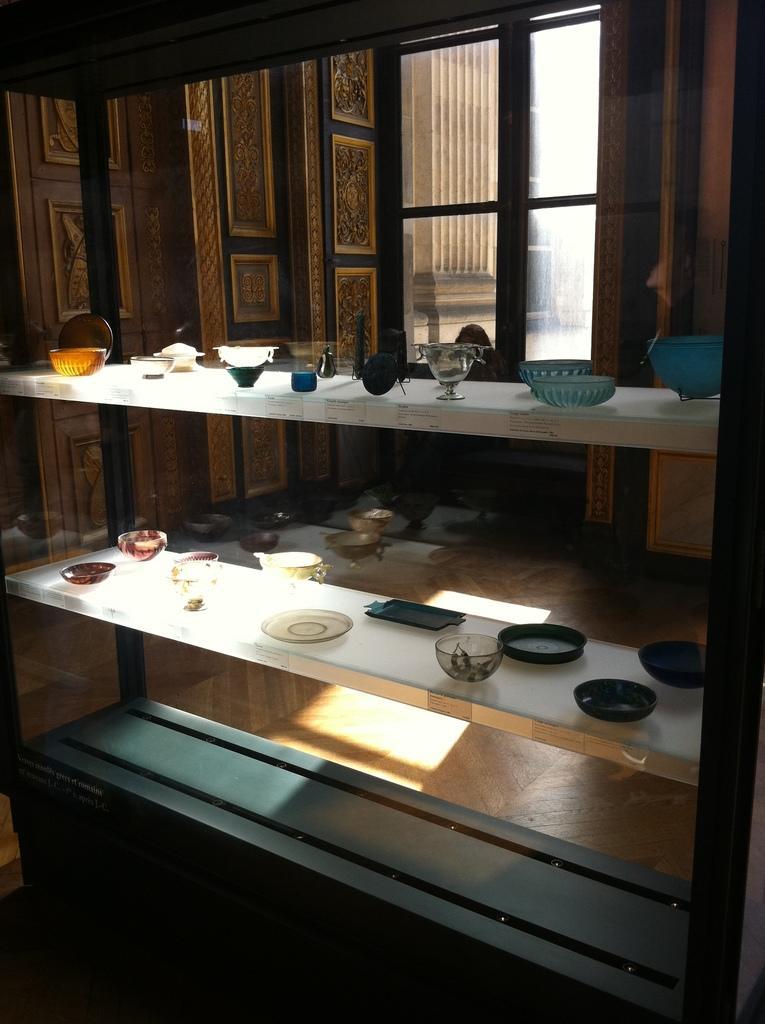In one or two sentences, can you explain what this image depicts? In this Image there are few objects made out of glass are placed on the shelves, behind the shelves there is a window. 